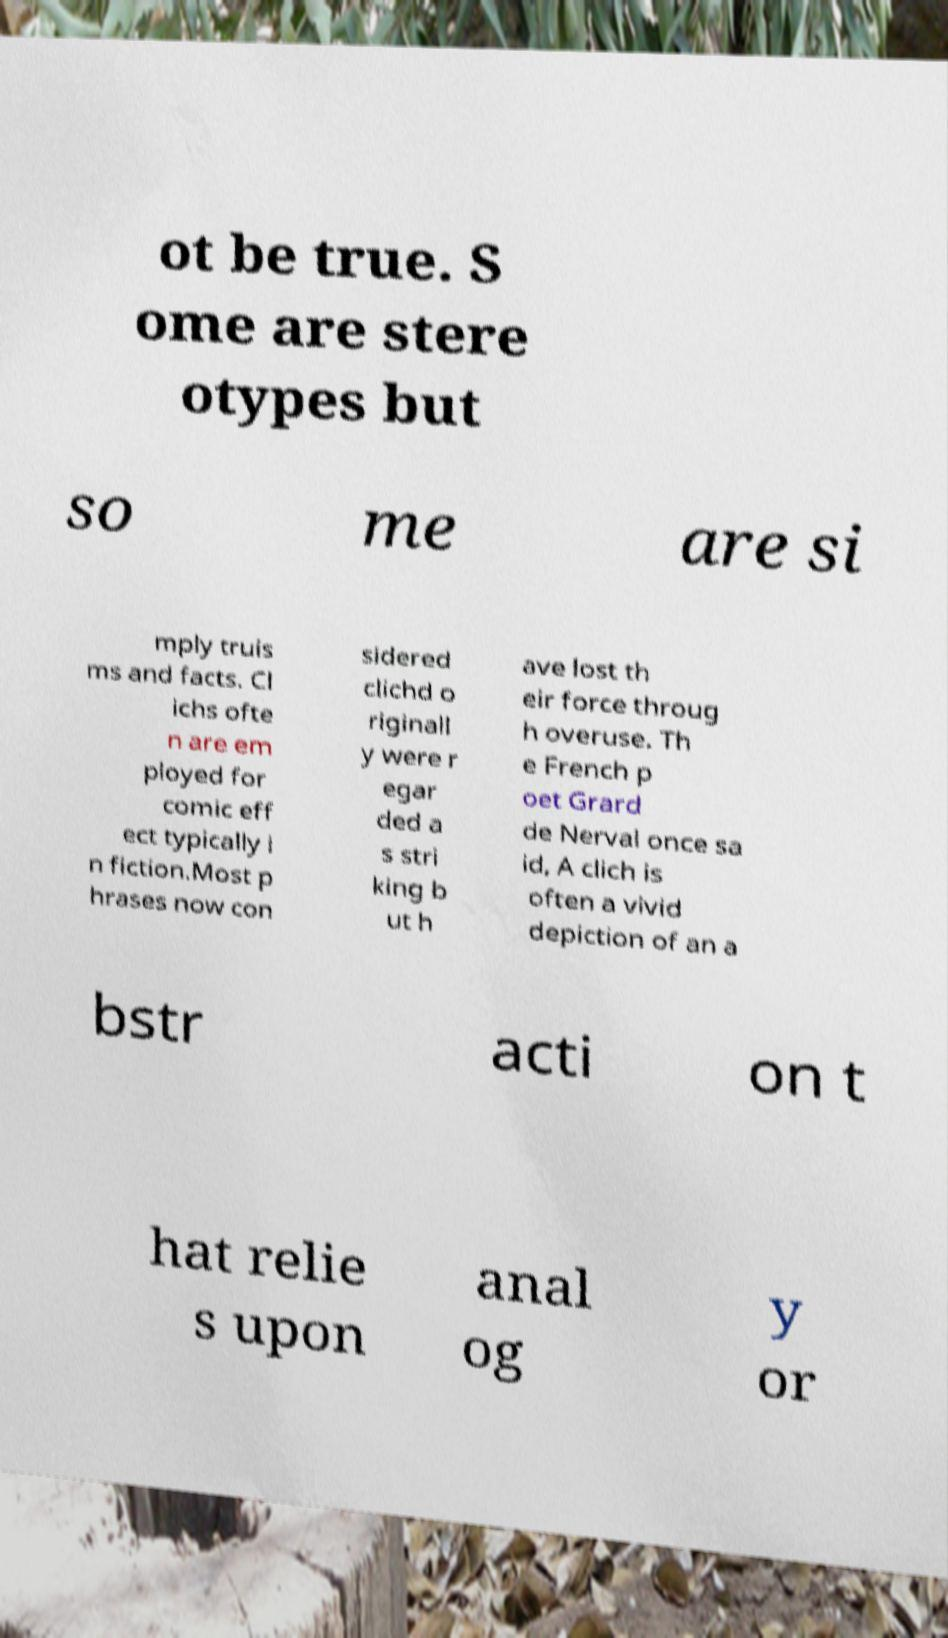Could you assist in decoding the text presented in this image and type it out clearly? ot be true. S ome are stere otypes but so me are si mply truis ms and facts. Cl ichs ofte n are em ployed for comic eff ect typically i n fiction.Most p hrases now con sidered clichd o riginall y were r egar ded a s stri king b ut h ave lost th eir force throug h overuse. Th e French p oet Grard de Nerval once sa id, A clich is often a vivid depiction of an a bstr acti on t hat relie s upon anal og y or 